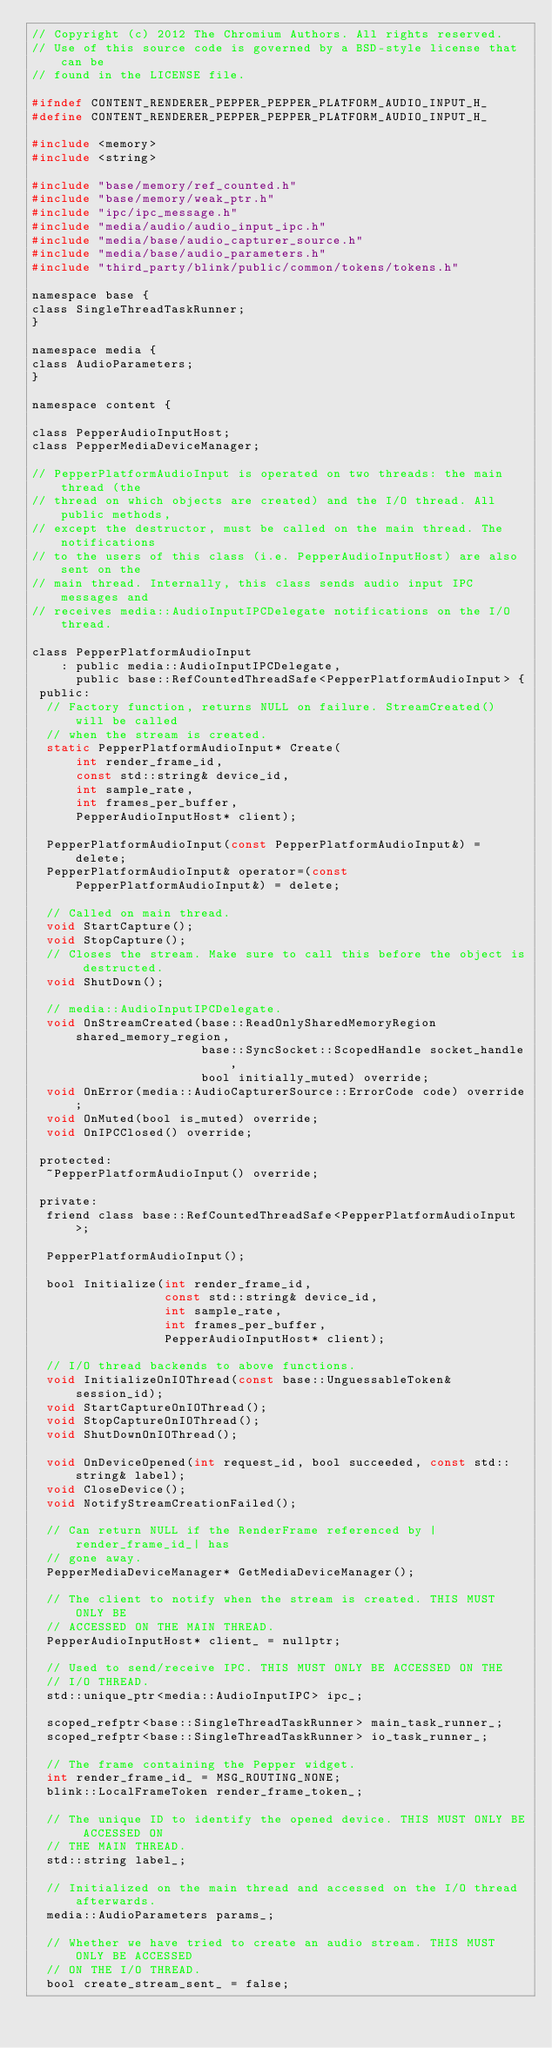<code> <loc_0><loc_0><loc_500><loc_500><_C_>// Copyright (c) 2012 The Chromium Authors. All rights reserved.
// Use of this source code is governed by a BSD-style license that can be
// found in the LICENSE file.

#ifndef CONTENT_RENDERER_PEPPER_PEPPER_PLATFORM_AUDIO_INPUT_H_
#define CONTENT_RENDERER_PEPPER_PEPPER_PLATFORM_AUDIO_INPUT_H_

#include <memory>
#include <string>

#include "base/memory/ref_counted.h"
#include "base/memory/weak_ptr.h"
#include "ipc/ipc_message.h"
#include "media/audio/audio_input_ipc.h"
#include "media/base/audio_capturer_source.h"
#include "media/base/audio_parameters.h"
#include "third_party/blink/public/common/tokens/tokens.h"

namespace base {
class SingleThreadTaskRunner;
}

namespace media {
class AudioParameters;
}

namespace content {

class PepperAudioInputHost;
class PepperMediaDeviceManager;

// PepperPlatformAudioInput is operated on two threads: the main thread (the
// thread on which objects are created) and the I/O thread. All public methods,
// except the destructor, must be called on the main thread. The notifications
// to the users of this class (i.e. PepperAudioInputHost) are also sent on the
// main thread. Internally, this class sends audio input IPC messages and
// receives media::AudioInputIPCDelegate notifications on the I/O thread.

class PepperPlatformAudioInput
    : public media::AudioInputIPCDelegate,
      public base::RefCountedThreadSafe<PepperPlatformAudioInput> {
 public:
  // Factory function, returns NULL on failure. StreamCreated() will be called
  // when the stream is created.
  static PepperPlatformAudioInput* Create(
      int render_frame_id,
      const std::string& device_id,
      int sample_rate,
      int frames_per_buffer,
      PepperAudioInputHost* client);

  PepperPlatformAudioInput(const PepperPlatformAudioInput&) = delete;
  PepperPlatformAudioInput& operator=(const PepperPlatformAudioInput&) = delete;

  // Called on main thread.
  void StartCapture();
  void StopCapture();
  // Closes the stream. Make sure to call this before the object is destructed.
  void ShutDown();

  // media::AudioInputIPCDelegate.
  void OnStreamCreated(base::ReadOnlySharedMemoryRegion shared_memory_region,
                       base::SyncSocket::ScopedHandle socket_handle,
                       bool initially_muted) override;
  void OnError(media::AudioCapturerSource::ErrorCode code) override;
  void OnMuted(bool is_muted) override;
  void OnIPCClosed() override;

 protected:
  ~PepperPlatformAudioInput() override;

 private:
  friend class base::RefCountedThreadSafe<PepperPlatformAudioInput>;

  PepperPlatformAudioInput();

  bool Initialize(int render_frame_id,
                  const std::string& device_id,
                  int sample_rate,
                  int frames_per_buffer,
                  PepperAudioInputHost* client);

  // I/O thread backends to above functions.
  void InitializeOnIOThread(const base::UnguessableToken& session_id);
  void StartCaptureOnIOThread();
  void StopCaptureOnIOThread();
  void ShutDownOnIOThread();

  void OnDeviceOpened(int request_id, bool succeeded, const std::string& label);
  void CloseDevice();
  void NotifyStreamCreationFailed();

  // Can return NULL if the RenderFrame referenced by |render_frame_id_| has
  // gone away.
  PepperMediaDeviceManager* GetMediaDeviceManager();

  // The client to notify when the stream is created. THIS MUST ONLY BE
  // ACCESSED ON THE MAIN THREAD.
  PepperAudioInputHost* client_ = nullptr;

  // Used to send/receive IPC. THIS MUST ONLY BE ACCESSED ON THE
  // I/O THREAD.
  std::unique_ptr<media::AudioInputIPC> ipc_;

  scoped_refptr<base::SingleThreadTaskRunner> main_task_runner_;
  scoped_refptr<base::SingleThreadTaskRunner> io_task_runner_;

  // The frame containing the Pepper widget.
  int render_frame_id_ = MSG_ROUTING_NONE;
  blink::LocalFrameToken render_frame_token_;

  // The unique ID to identify the opened device. THIS MUST ONLY BE ACCESSED ON
  // THE MAIN THREAD.
  std::string label_;

  // Initialized on the main thread and accessed on the I/O thread afterwards.
  media::AudioParameters params_;

  // Whether we have tried to create an audio stream. THIS MUST ONLY BE ACCESSED
  // ON THE I/O THREAD.
  bool create_stream_sent_ = false;
</code> 